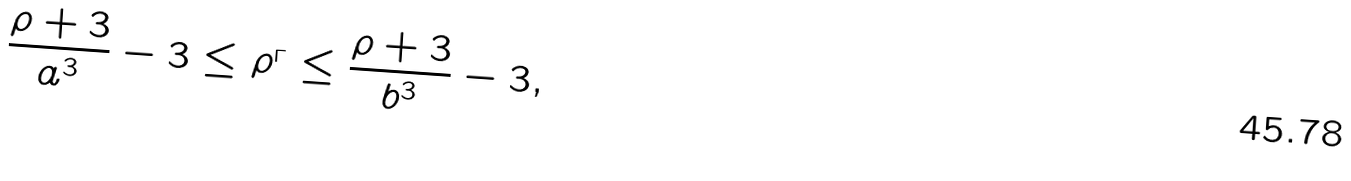<formula> <loc_0><loc_0><loc_500><loc_500>\frac { \rho + 3 } { a ^ { 3 } } - 3 \leq \rho ^ { _ { \Gamma } } \leq \frac { \rho + 3 } { b ^ { 3 } } - 3 ,</formula> 